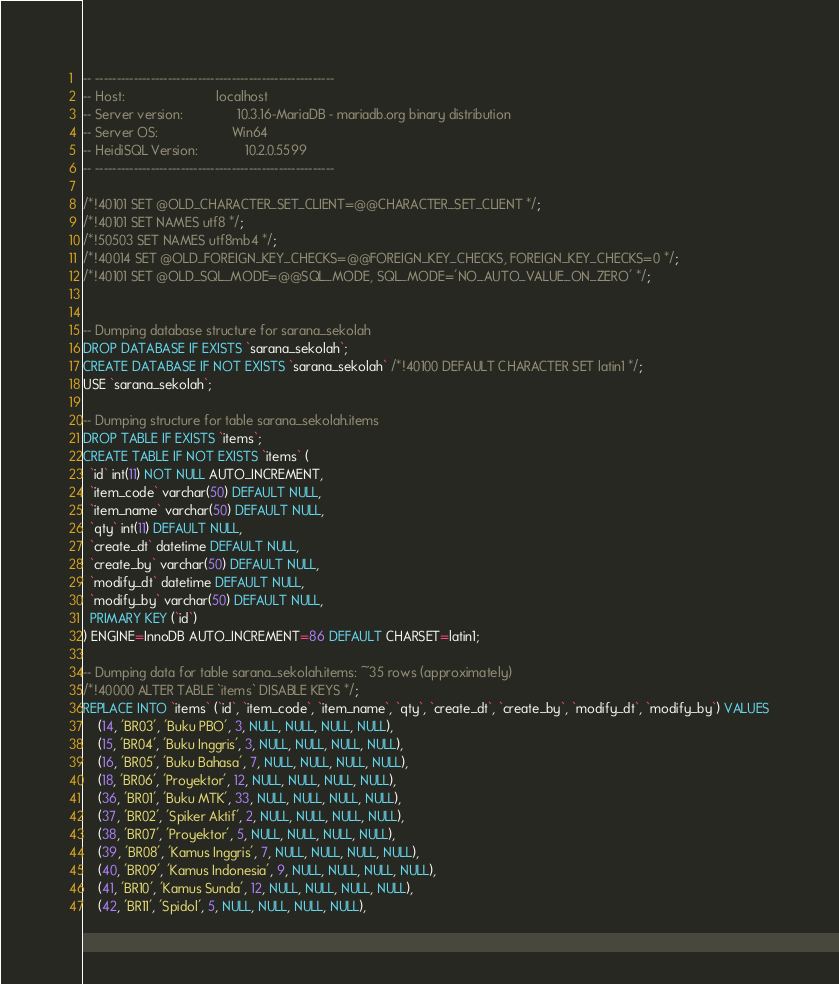<code> <loc_0><loc_0><loc_500><loc_500><_SQL_>-- --------------------------------------------------------
-- Host:                         localhost
-- Server version:               10.3.16-MariaDB - mariadb.org binary distribution
-- Server OS:                    Win64
-- HeidiSQL Version:             10.2.0.5599
-- --------------------------------------------------------

/*!40101 SET @OLD_CHARACTER_SET_CLIENT=@@CHARACTER_SET_CLIENT */;
/*!40101 SET NAMES utf8 */;
/*!50503 SET NAMES utf8mb4 */;
/*!40014 SET @OLD_FOREIGN_KEY_CHECKS=@@FOREIGN_KEY_CHECKS, FOREIGN_KEY_CHECKS=0 */;
/*!40101 SET @OLD_SQL_MODE=@@SQL_MODE, SQL_MODE='NO_AUTO_VALUE_ON_ZERO' */;


-- Dumping database structure for sarana_sekolah
DROP DATABASE IF EXISTS `sarana_sekolah`;
CREATE DATABASE IF NOT EXISTS `sarana_sekolah` /*!40100 DEFAULT CHARACTER SET latin1 */;
USE `sarana_sekolah`;

-- Dumping structure for table sarana_sekolah.items
DROP TABLE IF EXISTS `items`;
CREATE TABLE IF NOT EXISTS `items` (
  `id` int(11) NOT NULL AUTO_INCREMENT,
  `item_code` varchar(50) DEFAULT NULL,
  `item_name` varchar(50) DEFAULT NULL,
  `qty` int(11) DEFAULT NULL,
  `create_dt` datetime DEFAULT NULL,
  `create_by` varchar(50) DEFAULT NULL,
  `modify_dt` datetime DEFAULT NULL,
  `modify_by` varchar(50) DEFAULT NULL,
  PRIMARY KEY (`id`)
) ENGINE=InnoDB AUTO_INCREMENT=86 DEFAULT CHARSET=latin1;

-- Dumping data for table sarana_sekolah.items: ~35 rows (approximately)
/*!40000 ALTER TABLE `items` DISABLE KEYS */;
REPLACE INTO `items` (`id`, `item_code`, `item_name`, `qty`, `create_dt`, `create_by`, `modify_dt`, `modify_by`) VALUES
	(14, 'BR03', 'Buku PBO', 3, NULL, NULL, NULL, NULL),
	(15, 'BR04', 'Buku Inggris', 3, NULL, NULL, NULL, NULL),
	(16, 'BR05', 'Buku Bahasa', 7, NULL, NULL, NULL, NULL),
	(18, 'BR06', 'Proyektor', 12, NULL, NULL, NULL, NULL),
	(36, 'BR01', 'Buku MTK', 33, NULL, NULL, NULL, NULL),
	(37, 'BR02', 'Spiker Aktif', 2, NULL, NULL, NULL, NULL),
	(38, 'BR07', 'Proyektor', 5, NULL, NULL, NULL, NULL),
	(39, 'BR08', 'Kamus Inggris', 7, NULL, NULL, NULL, NULL),
	(40, 'BR09', 'Kamus Indonesia', 9, NULL, NULL, NULL, NULL),
	(41, 'BR10', 'Kamus Sunda', 12, NULL, NULL, NULL, NULL),
	(42, 'BR11', 'Spidol', 5, NULL, NULL, NULL, NULL),</code> 